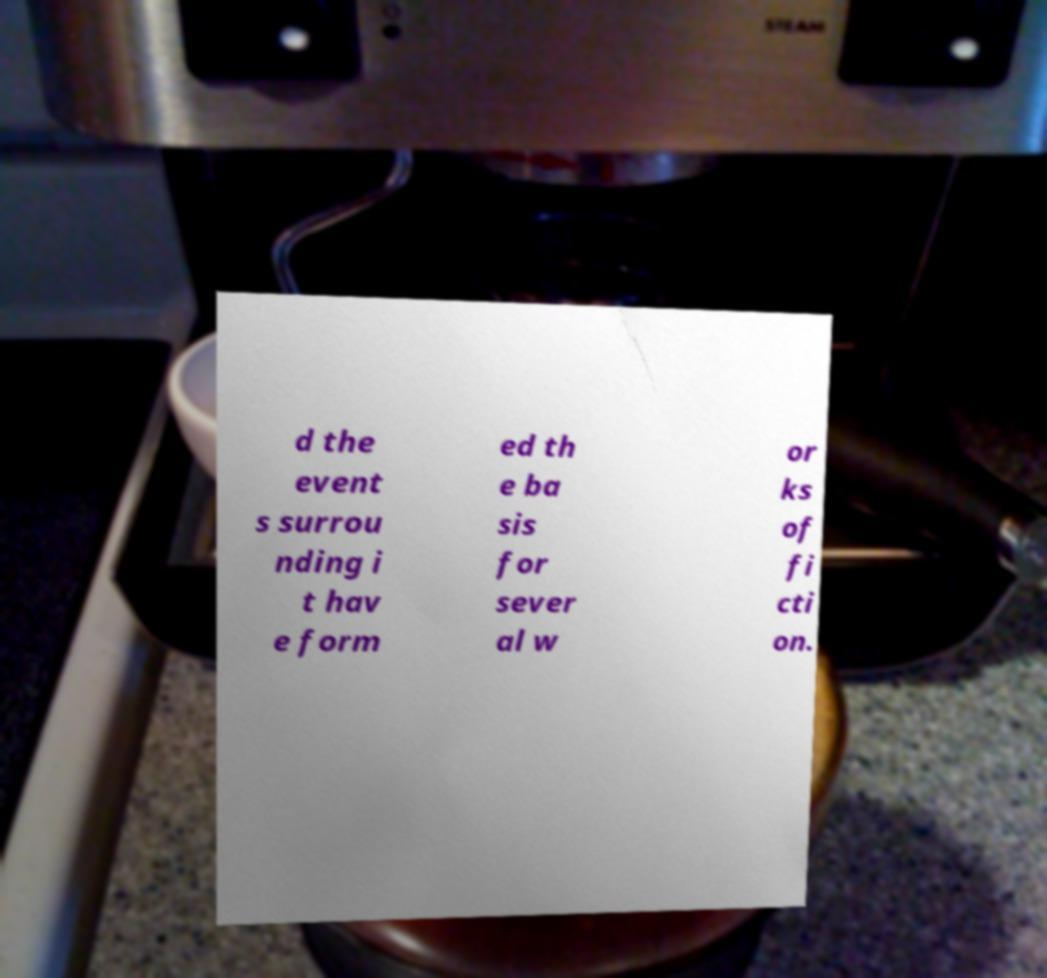I need the written content from this picture converted into text. Can you do that? d the event s surrou nding i t hav e form ed th e ba sis for sever al w or ks of fi cti on. 